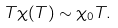Convert formula to latex. <formula><loc_0><loc_0><loc_500><loc_500>T \chi ( T ) \sim \chi _ { 0 } T .</formula> 